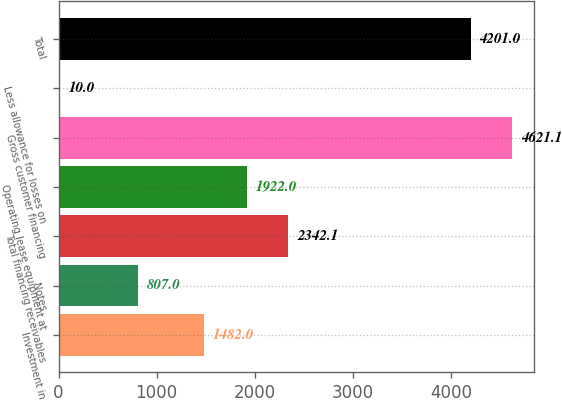Convert chart. <chart><loc_0><loc_0><loc_500><loc_500><bar_chart><fcel>Investment in<fcel>Notes<fcel>Total financing receivables<fcel>Operating lease equipment at<fcel>Gross customer financing<fcel>Less allowance for losses on<fcel>Total<nl><fcel>1482<fcel>807<fcel>2342.1<fcel>1922<fcel>4621.1<fcel>10<fcel>4201<nl></chart> 